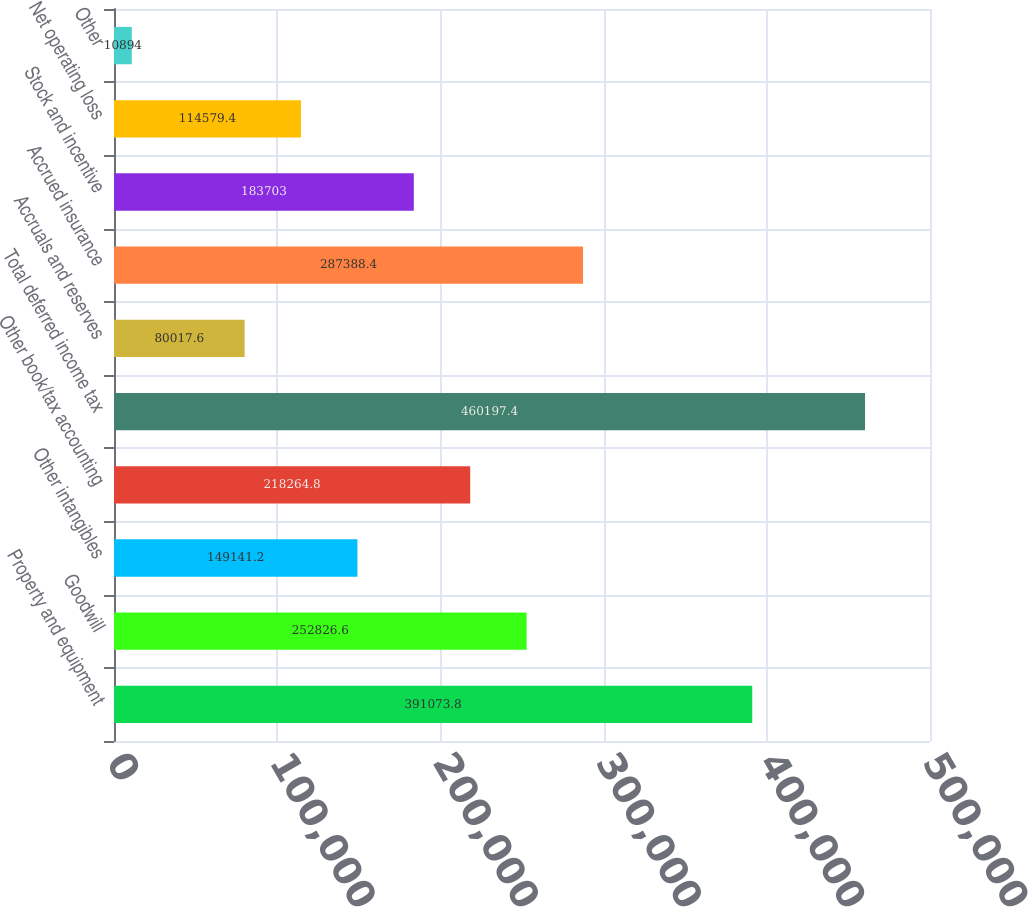Convert chart to OTSL. <chart><loc_0><loc_0><loc_500><loc_500><bar_chart><fcel>Property and equipment<fcel>Goodwill<fcel>Other intangibles<fcel>Other book/tax accounting<fcel>Total deferred income tax<fcel>Accruals and reserves<fcel>Accrued insurance<fcel>Stock and incentive<fcel>Net operating loss<fcel>Other<nl><fcel>391074<fcel>252827<fcel>149141<fcel>218265<fcel>460197<fcel>80017.6<fcel>287388<fcel>183703<fcel>114579<fcel>10894<nl></chart> 